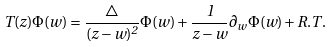Convert formula to latex. <formula><loc_0><loc_0><loc_500><loc_500>T ( z ) \Phi ( w ) = \frac { \bigtriangleup } { ( z - w ) ^ { 2 } } \Phi ( w ) + \frac { 1 } { z - w } \partial _ { w } \Phi ( w ) + R . T .</formula> 